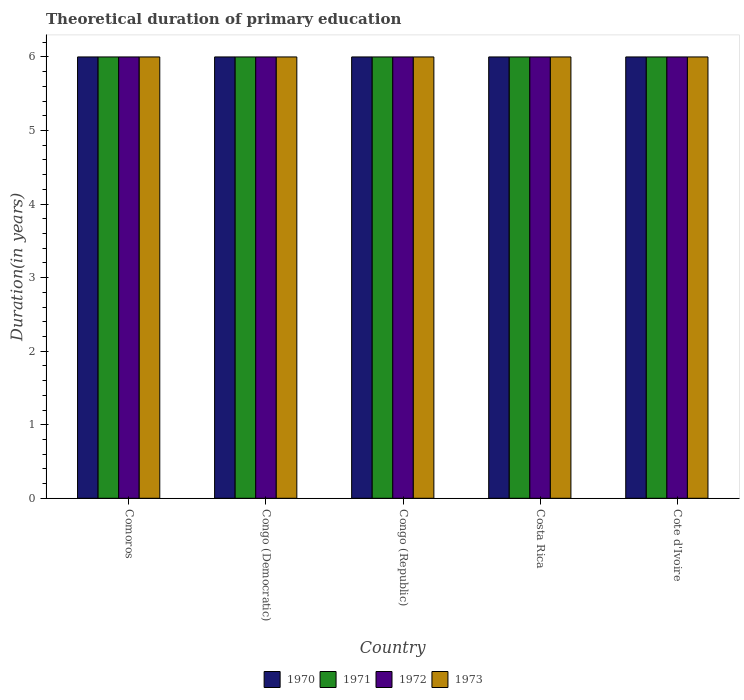How many different coloured bars are there?
Your answer should be compact. 4. How many groups of bars are there?
Offer a terse response. 5. Are the number of bars per tick equal to the number of legend labels?
Your answer should be compact. Yes. Are the number of bars on each tick of the X-axis equal?
Offer a very short reply. Yes. How many bars are there on the 1st tick from the left?
Make the answer very short. 4. What is the label of the 4th group of bars from the left?
Offer a very short reply. Costa Rica. In how many cases, is the number of bars for a given country not equal to the number of legend labels?
Your answer should be very brief. 0. In which country was the total theoretical duration of primary education in 1972 maximum?
Keep it short and to the point. Comoros. In which country was the total theoretical duration of primary education in 1970 minimum?
Provide a short and direct response. Comoros. What is the total total theoretical duration of primary education in 1973 in the graph?
Provide a succinct answer. 30. What is the difference between the total theoretical duration of primary education in 1972 in Comoros and that in Costa Rica?
Offer a very short reply. 0. What is the difference between the total theoretical duration of primary education of/in 1973 and total theoretical duration of primary education of/in 1972 in Costa Rica?
Your answer should be very brief. 0. In how many countries, is the total theoretical duration of primary education in 1973 greater than 5 years?
Give a very brief answer. 5. What is the ratio of the total theoretical duration of primary education in 1972 in Congo (Republic) to that in Cote d'Ivoire?
Offer a very short reply. 1. In how many countries, is the total theoretical duration of primary education in 1971 greater than the average total theoretical duration of primary education in 1971 taken over all countries?
Keep it short and to the point. 0. Is the sum of the total theoretical duration of primary education in 1971 in Costa Rica and Cote d'Ivoire greater than the maximum total theoretical duration of primary education in 1973 across all countries?
Make the answer very short. Yes. Is it the case that in every country, the sum of the total theoretical duration of primary education in 1971 and total theoretical duration of primary education in 1973 is greater than the sum of total theoretical duration of primary education in 1970 and total theoretical duration of primary education in 1972?
Your answer should be compact. No. What does the 4th bar from the left in Comoros represents?
Provide a short and direct response. 1973. What does the 1st bar from the right in Costa Rica represents?
Your answer should be very brief. 1973. Is it the case that in every country, the sum of the total theoretical duration of primary education in 1970 and total theoretical duration of primary education in 1971 is greater than the total theoretical duration of primary education in 1973?
Provide a succinct answer. Yes. Are all the bars in the graph horizontal?
Make the answer very short. No. How many countries are there in the graph?
Your answer should be compact. 5. What is the difference between two consecutive major ticks on the Y-axis?
Provide a succinct answer. 1. Does the graph contain any zero values?
Keep it short and to the point. No. Where does the legend appear in the graph?
Your answer should be compact. Bottom center. How are the legend labels stacked?
Provide a succinct answer. Horizontal. What is the title of the graph?
Ensure brevity in your answer.  Theoretical duration of primary education. Does "2013" appear as one of the legend labels in the graph?
Your response must be concise. No. What is the label or title of the X-axis?
Your answer should be compact. Country. What is the label or title of the Y-axis?
Provide a succinct answer. Duration(in years). What is the Duration(in years) of 1971 in Comoros?
Offer a very short reply. 6. What is the Duration(in years) of 1972 in Comoros?
Provide a succinct answer. 6. What is the Duration(in years) of 1972 in Congo (Democratic)?
Your answer should be very brief. 6. What is the Duration(in years) in 1973 in Congo (Democratic)?
Offer a terse response. 6. What is the Duration(in years) in 1970 in Congo (Republic)?
Offer a terse response. 6. What is the Duration(in years) of 1973 in Congo (Republic)?
Your answer should be very brief. 6. What is the Duration(in years) in 1971 in Costa Rica?
Ensure brevity in your answer.  6. Across all countries, what is the maximum Duration(in years) of 1970?
Give a very brief answer. 6. Across all countries, what is the minimum Duration(in years) of 1972?
Provide a short and direct response. 6. Across all countries, what is the minimum Duration(in years) in 1973?
Keep it short and to the point. 6. What is the total Duration(in years) of 1971 in the graph?
Provide a succinct answer. 30. What is the total Duration(in years) in 1972 in the graph?
Offer a terse response. 30. What is the total Duration(in years) of 1973 in the graph?
Ensure brevity in your answer.  30. What is the difference between the Duration(in years) of 1970 in Comoros and that in Congo (Democratic)?
Your response must be concise. 0. What is the difference between the Duration(in years) of 1973 in Comoros and that in Congo (Democratic)?
Offer a very short reply. 0. What is the difference between the Duration(in years) of 1971 in Comoros and that in Congo (Republic)?
Your answer should be very brief. 0. What is the difference between the Duration(in years) in 1971 in Comoros and that in Costa Rica?
Your response must be concise. 0. What is the difference between the Duration(in years) in 1973 in Comoros and that in Costa Rica?
Provide a succinct answer. 0. What is the difference between the Duration(in years) in 1970 in Comoros and that in Cote d'Ivoire?
Make the answer very short. 0. What is the difference between the Duration(in years) of 1971 in Comoros and that in Cote d'Ivoire?
Give a very brief answer. 0. What is the difference between the Duration(in years) in 1972 in Comoros and that in Cote d'Ivoire?
Your answer should be compact. 0. What is the difference between the Duration(in years) of 1972 in Congo (Democratic) and that in Congo (Republic)?
Your answer should be very brief. 0. What is the difference between the Duration(in years) in 1973 in Congo (Democratic) and that in Congo (Republic)?
Your answer should be compact. 0. What is the difference between the Duration(in years) of 1973 in Congo (Democratic) and that in Cote d'Ivoire?
Keep it short and to the point. 0. What is the difference between the Duration(in years) in 1971 in Congo (Republic) and that in Costa Rica?
Make the answer very short. 0. What is the difference between the Duration(in years) of 1972 in Congo (Republic) and that in Costa Rica?
Provide a succinct answer. 0. What is the difference between the Duration(in years) of 1970 in Congo (Republic) and that in Cote d'Ivoire?
Your response must be concise. 0. What is the difference between the Duration(in years) in 1971 in Congo (Republic) and that in Cote d'Ivoire?
Make the answer very short. 0. What is the difference between the Duration(in years) in 1973 in Congo (Republic) and that in Cote d'Ivoire?
Give a very brief answer. 0. What is the difference between the Duration(in years) in 1971 in Costa Rica and that in Cote d'Ivoire?
Ensure brevity in your answer.  0. What is the difference between the Duration(in years) of 1970 in Comoros and the Duration(in years) of 1971 in Congo (Democratic)?
Keep it short and to the point. 0. What is the difference between the Duration(in years) in 1970 in Comoros and the Duration(in years) in 1972 in Congo (Democratic)?
Make the answer very short. 0. What is the difference between the Duration(in years) in 1971 in Comoros and the Duration(in years) in 1972 in Congo (Democratic)?
Your response must be concise. 0. What is the difference between the Duration(in years) of 1972 in Comoros and the Duration(in years) of 1973 in Congo (Democratic)?
Provide a succinct answer. 0. What is the difference between the Duration(in years) of 1972 in Comoros and the Duration(in years) of 1973 in Congo (Republic)?
Make the answer very short. 0. What is the difference between the Duration(in years) of 1970 in Comoros and the Duration(in years) of 1971 in Costa Rica?
Make the answer very short. 0. What is the difference between the Duration(in years) of 1970 in Comoros and the Duration(in years) of 1972 in Costa Rica?
Your answer should be compact. 0. What is the difference between the Duration(in years) in 1970 in Comoros and the Duration(in years) in 1973 in Costa Rica?
Your answer should be very brief. 0. What is the difference between the Duration(in years) in 1971 in Comoros and the Duration(in years) in 1973 in Costa Rica?
Your response must be concise. 0. What is the difference between the Duration(in years) of 1972 in Comoros and the Duration(in years) of 1973 in Costa Rica?
Offer a very short reply. 0. What is the difference between the Duration(in years) of 1970 in Comoros and the Duration(in years) of 1971 in Cote d'Ivoire?
Give a very brief answer. 0. What is the difference between the Duration(in years) of 1971 in Comoros and the Duration(in years) of 1972 in Cote d'Ivoire?
Your answer should be very brief. 0. What is the difference between the Duration(in years) of 1971 in Comoros and the Duration(in years) of 1973 in Cote d'Ivoire?
Keep it short and to the point. 0. What is the difference between the Duration(in years) of 1970 in Congo (Democratic) and the Duration(in years) of 1971 in Congo (Republic)?
Your answer should be very brief. 0. What is the difference between the Duration(in years) in 1970 in Congo (Democratic) and the Duration(in years) in 1973 in Congo (Republic)?
Your answer should be very brief. 0. What is the difference between the Duration(in years) in 1972 in Congo (Democratic) and the Duration(in years) in 1973 in Congo (Republic)?
Ensure brevity in your answer.  0. What is the difference between the Duration(in years) of 1970 in Congo (Democratic) and the Duration(in years) of 1971 in Costa Rica?
Your response must be concise. 0. What is the difference between the Duration(in years) of 1972 in Congo (Democratic) and the Duration(in years) of 1973 in Costa Rica?
Your answer should be very brief. 0. What is the difference between the Duration(in years) of 1970 in Congo (Democratic) and the Duration(in years) of 1973 in Cote d'Ivoire?
Make the answer very short. 0. What is the difference between the Duration(in years) in 1971 in Congo (Democratic) and the Duration(in years) in 1973 in Cote d'Ivoire?
Provide a short and direct response. 0. What is the difference between the Duration(in years) in 1970 in Congo (Republic) and the Duration(in years) in 1971 in Costa Rica?
Provide a short and direct response. 0. What is the difference between the Duration(in years) in 1970 in Congo (Republic) and the Duration(in years) in 1972 in Costa Rica?
Make the answer very short. 0. What is the difference between the Duration(in years) in 1970 in Congo (Republic) and the Duration(in years) in 1973 in Costa Rica?
Offer a very short reply. 0. What is the difference between the Duration(in years) in 1970 in Congo (Republic) and the Duration(in years) in 1972 in Cote d'Ivoire?
Offer a very short reply. 0. What is the difference between the Duration(in years) of 1972 in Congo (Republic) and the Duration(in years) of 1973 in Cote d'Ivoire?
Give a very brief answer. 0. What is the difference between the Duration(in years) in 1970 in Costa Rica and the Duration(in years) in 1972 in Cote d'Ivoire?
Give a very brief answer. 0. What is the difference between the Duration(in years) of 1970 in Costa Rica and the Duration(in years) of 1973 in Cote d'Ivoire?
Your response must be concise. 0. What is the average Duration(in years) of 1970 per country?
Offer a terse response. 6. What is the difference between the Duration(in years) in 1970 and Duration(in years) in 1971 in Comoros?
Ensure brevity in your answer.  0. What is the difference between the Duration(in years) of 1970 and Duration(in years) of 1973 in Comoros?
Offer a very short reply. 0. What is the difference between the Duration(in years) in 1972 and Duration(in years) in 1973 in Comoros?
Offer a terse response. 0. What is the difference between the Duration(in years) in 1970 and Duration(in years) in 1971 in Congo (Democratic)?
Ensure brevity in your answer.  0. What is the difference between the Duration(in years) of 1970 and Duration(in years) of 1973 in Congo (Democratic)?
Give a very brief answer. 0. What is the difference between the Duration(in years) in 1971 and Duration(in years) in 1972 in Congo (Democratic)?
Your answer should be compact. 0. What is the difference between the Duration(in years) in 1970 and Duration(in years) in 1971 in Congo (Republic)?
Your response must be concise. 0. What is the difference between the Duration(in years) in 1970 and Duration(in years) in 1972 in Congo (Republic)?
Your answer should be compact. 0. What is the difference between the Duration(in years) in 1970 and Duration(in years) in 1973 in Congo (Republic)?
Provide a succinct answer. 0. What is the difference between the Duration(in years) in 1971 and Duration(in years) in 1972 in Congo (Republic)?
Provide a succinct answer. 0. What is the difference between the Duration(in years) in 1971 and Duration(in years) in 1973 in Congo (Republic)?
Your answer should be very brief. 0. What is the difference between the Duration(in years) of 1970 and Duration(in years) of 1971 in Costa Rica?
Provide a short and direct response. 0. What is the difference between the Duration(in years) in 1970 and Duration(in years) in 1972 in Costa Rica?
Make the answer very short. 0. What is the difference between the Duration(in years) of 1970 and Duration(in years) of 1973 in Costa Rica?
Make the answer very short. 0. What is the difference between the Duration(in years) in 1971 and Duration(in years) in 1972 in Costa Rica?
Ensure brevity in your answer.  0. What is the difference between the Duration(in years) in 1971 and Duration(in years) in 1973 in Costa Rica?
Provide a succinct answer. 0. What is the difference between the Duration(in years) of 1972 and Duration(in years) of 1973 in Costa Rica?
Your answer should be very brief. 0. What is the difference between the Duration(in years) of 1970 and Duration(in years) of 1971 in Cote d'Ivoire?
Your response must be concise. 0. What is the ratio of the Duration(in years) in 1970 in Comoros to that in Congo (Democratic)?
Your answer should be compact. 1. What is the ratio of the Duration(in years) in 1970 in Comoros to that in Congo (Republic)?
Provide a short and direct response. 1. What is the ratio of the Duration(in years) in 1972 in Comoros to that in Congo (Republic)?
Make the answer very short. 1. What is the ratio of the Duration(in years) of 1973 in Comoros to that in Congo (Republic)?
Make the answer very short. 1. What is the ratio of the Duration(in years) of 1971 in Comoros to that in Costa Rica?
Offer a very short reply. 1. What is the ratio of the Duration(in years) of 1973 in Comoros to that in Costa Rica?
Your answer should be compact. 1. What is the ratio of the Duration(in years) of 1970 in Comoros to that in Cote d'Ivoire?
Your answer should be very brief. 1. What is the ratio of the Duration(in years) of 1971 in Comoros to that in Cote d'Ivoire?
Give a very brief answer. 1. What is the ratio of the Duration(in years) in 1973 in Comoros to that in Cote d'Ivoire?
Provide a succinct answer. 1. What is the ratio of the Duration(in years) in 1970 in Congo (Democratic) to that in Congo (Republic)?
Ensure brevity in your answer.  1. What is the ratio of the Duration(in years) in 1971 in Congo (Democratic) to that in Congo (Republic)?
Give a very brief answer. 1. What is the ratio of the Duration(in years) of 1973 in Congo (Democratic) to that in Congo (Republic)?
Provide a short and direct response. 1. What is the ratio of the Duration(in years) in 1970 in Congo (Democratic) to that in Costa Rica?
Ensure brevity in your answer.  1. What is the ratio of the Duration(in years) in 1971 in Congo (Democratic) to that in Costa Rica?
Ensure brevity in your answer.  1. What is the ratio of the Duration(in years) of 1973 in Congo (Democratic) to that in Costa Rica?
Your response must be concise. 1. What is the ratio of the Duration(in years) in 1972 in Congo (Democratic) to that in Cote d'Ivoire?
Keep it short and to the point. 1. What is the ratio of the Duration(in years) of 1971 in Congo (Republic) to that in Costa Rica?
Keep it short and to the point. 1. What is the ratio of the Duration(in years) of 1972 in Congo (Republic) to that in Costa Rica?
Your answer should be very brief. 1. What is the ratio of the Duration(in years) in 1973 in Congo (Republic) to that in Costa Rica?
Your response must be concise. 1. What is the ratio of the Duration(in years) of 1970 in Congo (Republic) to that in Cote d'Ivoire?
Provide a succinct answer. 1. What is the ratio of the Duration(in years) in 1971 in Congo (Republic) to that in Cote d'Ivoire?
Keep it short and to the point. 1. What is the ratio of the Duration(in years) of 1973 in Congo (Republic) to that in Cote d'Ivoire?
Make the answer very short. 1. What is the ratio of the Duration(in years) in 1971 in Costa Rica to that in Cote d'Ivoire?
Provide a succinct answer. 1. What is the ratio of the Duration(in years) of 1973 in Costa Rica to that in Cote d'Ivoire?
Offer a very short reply. 1. What is the difference between the highest and the second highest Duration(in years) in 1972?
Offer a terse response. 0. What is the difference between the highest and the lowest Duration(in years) in 1972?
Your answer should be very brief. 0. What is the difference between the highest and the lowest Duration(in years) in 1973?
Ensure brevity in your answer.  0. 